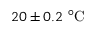Convert formula to latex. <formula><loc_0><loc_0><loc_500><loc_500>2 0 \pm 0 . 2 \ ^ { \circ } C</formula> 